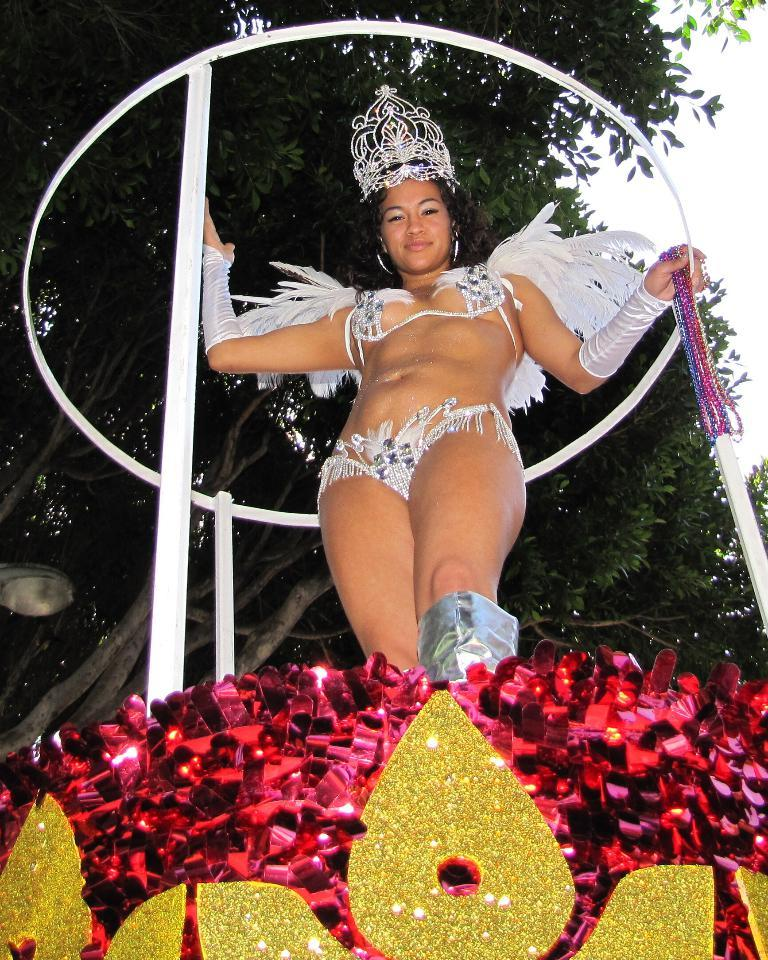What is the main subject of the image? There is a person standing in the image. What is the person standing on? The person is standing on a red color design stand. What can be seen in the background of the image? The sky is visible at the top of the image. How many children are playing in the image? There are no children present in the image, only a person standing on a red color design stand. What is the starting point of the women's race in the image? There are no women or race present in the image; it only features a person standing on a red color design stand. 